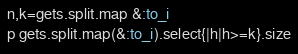Convert code to text. <code><loc_0><loc_0><loc_500><loc_500><_Ruby_>n,k=gets.split.map &:to_i
p gets.split.map(&:to_i).select{|h|h>=k}.size
</code> 